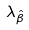<formula> <loc_0><loc_0><loc_500><loc_500>\lambda _ { \hat { \beta } }</formula> 